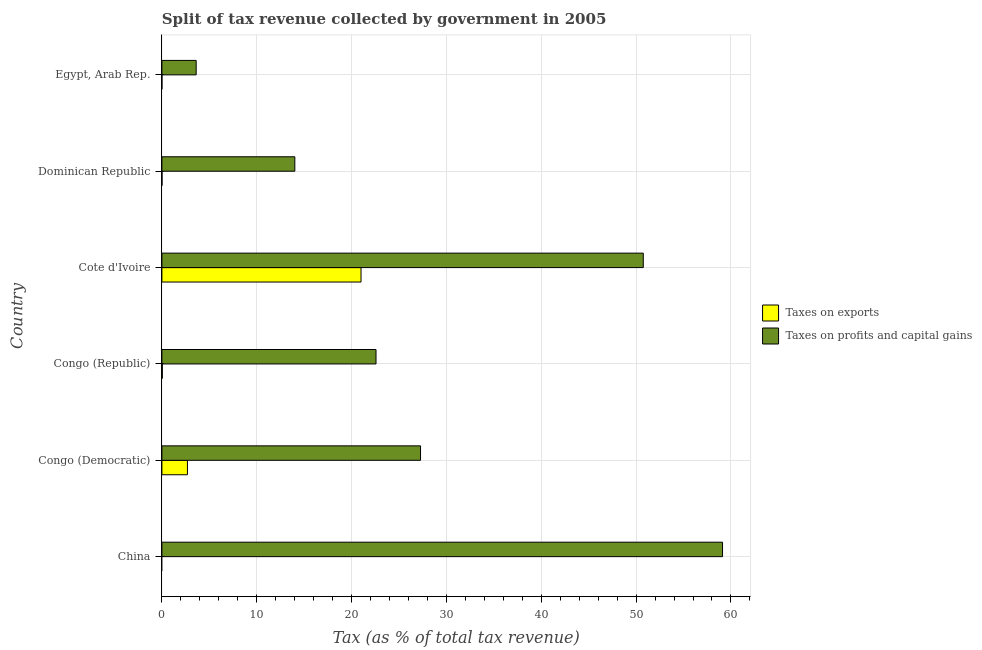How many different coloured bars are there?
Provide a succinct answer. 2. How many bars are there on the 3rd tick from the top?
Provide a short and direct response. 2. What is the label of the 5th group of bars from the top?
Give a very brief answer. Congo (Democratic). In how many cases, is the number of bars for a given country not equal to the number of legend labels?
Ensure brevity in your answer.  1. What is the percentage of revenue obtained from taxes on exports in Congo (Democratic)?
Offer a terse response. 2.69. Across all countries, what is the maximum percentage of revenue obtained from taxes on profits and capital gains?
Your response must be concise. 59.11. Across all countries, what is the minimum percentage of revenue obtained from taxes on exports?
Your response must be concise. 0. In which country was the percentage of revenue obtained from taxes on exports maximum?
Make the answer very short. Cote d'Ivoire. What is the total percentage of revenue obtained from taxes on profits and capital gains in the graph?
Provide a succinct answer. 177.34. What is the difference between the percentage of revenue obtained from taxes on profits and capital gains in Congo (Republic) and that in Cote d'Ivoire?
Provide a succinct answer. -28.18. What is the difference between the percentage of revenue obtained from taxes on exports in Dominican Republic and the percentage of revenue obtained from taxes on profits and capital gains in Cote d'Ivoire?
Your answer should be very brief. -50.75. What is the average percentage of revenue obtained from taxes on profits and capital gains per country?
Keep it short and to the point. 29.56. What is the difference between the percentage of revenue obtained from taxes on exports and percentage of revenue obtained from taxes on profits and capital gains in Congo (Republic)?
Your answer should be very brief. -22.53. In how many countries, is the percentage of revenue obtained from taxes on profits and capital gains greater than 54 %?
Give a very brief answer. 1. What is the ratio of the percentage of revenue obtained from taxes on profits and capital gains in Congo (Democratic) to that in Egypt, Arab Rep.?
Provide a short and direct response. 7.55. Is the percentage of revenue obtained from taxes on exports in Cote d'Ivoire less than that in Egypt, Arab Rep.?
Your answer should be compact. No. What is the difference between the highest and the second highest percentage of revenue obtained from taxes on profits and capital gains?
Offer a terse response. 8.36. What is the difference between the highest and the lowest percentage of revenue obtained from taxes on profits and capital gains?
Ensure brevity in your answer.  55.5. Is the sum of the percentage of revenue obtained from taxes on profits and capital gains in China and Cote d'Ivoire greater than the maximum percentage of revenue obtained from taxes on exports across all countries?
Make the answer very short. Yes. Are the values on the major ticks of X-axis written in scientific E-notation?
Give a very brief answer. No. How are the legend labels stacked?
Your answer should be compact. Vertical. What is the title of the graph?
Offer a very short reply. Split of tax revenue collected by government in 2005. What is the label or title of the X-axis?
Your response must be concise. Tax (as % of total tax revenue). What is the label or title of the Y-axis?
Ensure brevity in your answer.  Country. What is the Tax (as % of total tax revenue) of Taxes on profits and capital gains in China?
Provide a succinct answer. 59.11. What is the Tax (as % of total tax revenue) of Taxes on exports in Congo (Democratic)?
Provide a succinct answer. 2.69. What is the Tax (as % of total tax revenue) of Taxes on profits and capital gains in Congo (Democratic)?
Your response must be concise. 27.27. What is the Tax (as % of total tax revenue) in Taxes on exports in Congo (Republic)?
Offer a very short reply. 0.05. What is the Tax (as % of total tax revenue) in Taxes on profits and capital gains in Congo (Republic)?
Make the answer very short. 22.58. What is the Tax (as % of total tax revenue) of Taxes on exports in Cote d'Ivoire?
Keep it short and to the point. 21. What is the Tax (as % of total tax revenue) of Taxes on profits and capital gains in Cote d'Ivoire?
Offer a terse response. 50.76. What is the Tax (as % of total tax revenue) of Taxes on exports in Dominican Republic?
Make the answer very short. 0.01. What is the Tax (as % of total tax revenue) of Taxes on profits and capital gains in Dominican Republic?
Your answer should be compact. 14.02. What is the Tax (as % of total tax revenue) in Taxes on exports in Egypt, Arab Rep.?
Your answer should be compact. 0. What is the Tax (as % of total tax revenue) in Taxes on profits and capital gains in Egypt, Arab Rep.?
Provide a succinct answer. 3.61. Across all countries, what is the maximum Tax (as % of total tax revenue) of Taxes on exports?
Keep it short and to the point. 21. Across all countries, what is the maximum Tax (as % of total tax revenue) in Taxes on profits and capital gains?
Provide a short and direct response. 59.11. Across all countries, what is the minimum Tax (as % of total tax revenue) in Taxes on profits and capital gains?
Offer a terse response. 3.61. What is the total Tax (as % of total tax revenue) of Taxes on exports in the graph?
Provide a short and direct response. 23.74. What is the total Tax (as % of total tax revenue) of Taxes on profits and capital gains in the graph?
Ensure brevity in your answer.  177.34. What is the difference between the Tax (as % of total tax revenue) of Taxes on profits and capital gains in China and that in Congo (Democratic)?
Offer a terse response. 31.84. What is the difference between the Tax (as % of total tax revenue) of Taxes on profits and capital gains in China and that in Congo (Republic)?
Ensure brevity in your answer.  36.54. What is the difference between the Tax (as % of total tax revenue) of Taxes on profits and capital gains in China and that in Cote d'Ivoire?
Your response must be concise. 8.36. What is the difference between the Tax (as % of total tax revenue) of Taxes on profits and capital gains in China and that in Dominican Republic?
Offer a terse response. 45.1. What is the difference between the Tax (as % of total tax revenue) of Taxes on profits and capital gains in China and that in Egypt, Arab Rep.?
Make the answer very short. 55.5. What is the difference between the Tax (as % of total tax revenue) in Taxes on exports in Congo (Democratic) and that in Congo (Republic)?
Your response must be concise. 2.65. What is the difference between the Tax (as % of total tax revenue) of Taxes on profits and capital gains in Congo (Democratic) and that in Congo (Republic)?
Provide a succinct answer. 4.69. What is the difference between the Tax (as % of total tax revenue) in Taxes on exports in Congo (Democratic) and that in Cote d'Ivoire?
Ensure brevity in your answer.  -18.3. What is the difference between the Tax (as % of total tax revenue) of Taxes on profits and capital gains in Congo (Democratic) and that in Cote d'Ivoire?
Offer a very short reply. -23.49. What is the difference between the Tax (as % of total tax revenue) of Taxes on exports in Congo (Democratic) and that in Dominican Republic?
Ensure brevity in your answer.  2.68. What is the difference between the Tax (as % of total tax revenue) in Taxes on profits and capital gains in Congo (Democratic) and that in Dominican Republic?
Your answer should be compact. 13.25. What is the difference between the Tax (as % of total tax revenue) in Taxes on exports in Congo (Democratic) and that in Egypt, Arab Rep.?
Provide a succinct answer. 2.69. What is the difference between the Tax (as % of total tax revenue) of Taxes on profits and capital gains in Congo (Democratic) and that in Egypt, Arab Rep.?
Ensure brevity in your answer.  23.66. What is the difference between the Tax (as % of total tax revenue) of Taxes on exports in Congo (Republic) and that in Cote d'Ivoire?
Offer a terse response. -20.95. What is the difference between the Tax (as % of total tax revenue) of Taxes on profits and capital gains in Congo (Republic) and that in Cote d'Ivoire?
Offer a terse response. -28.18. What is the difference between the Tax (as % of total tax revenue) of Taxes on exports in Congo (Republic) and that in Dominican Republic?
Your answer should be very brief. 0.04. What is the difference between the Tax (as % of total tax revenue) in Taxes on profits and capital gains in Congo (Republic) and that in Dominican Republic?
Your answer should be very brief. 8.56. What is the difference between the Tax (as % of total tax revenue) in Taxes on exports in Congo (Republic) and that in Egypt, Arab Rep.?
Offer a terse response. 0.04. What is the difference between the Tax (as % of total tax revenue) in Taxes on profits and capital gains in Congo (Republic) and that in Egypt, Arab Rep.?
Provide a succinct answer. 18.96. What is the difference between the Tax (as % of total tax revenue) of Taxes on exports in Cote d'Ivoire and that in Dominican Republic?
Your answer should be compact. 20.99. What is the difference between the Tax (as % of total tax revenue) in Taxes on profits and capital gains in Cote d'Ivoire and that in Dominican Republic?
Offer a terse response. 36.74. What is the difference between the Tax (as % of total tax revenue) in Taxes on exports in Cote d'Ivoire and that in Egypt, Arab Rep.?
Your answer should be very brief. 20.99. What is the difference between the Tax (as % of total tax revenue) in Taxes on profits and capital gains in Cote d'Ivoire and that in Egypt, Arab Rep.?
Your answer should be compact. 47.14. What is the difference between the Tax (as % of total tax revenue) in Taxes on exports in Dominican Republic and that in Egypt, Arab Rep.?
Offer a terse response. 0.01. What is the difference between the Tax (as % of total tax revenue) in Taxes on profits and capital gains in Dominican Republic and that in Egypt, Arab Rep.?
Ensure brevity in your answer.  10.4. What is the difference between the Tax (as % of total tax revenue) in Taxes on exports in Congo (Democratic) and the Tax (as % of total tax revenue) in Taxes on profits and capital gains in Congo (Republic)?
Offer a terse response. -19.88. What is the difference between the Tax (as % of total tax revenue) of Taxes on exports in Congo (Democratic) and the Tax (as % of total tax revenue) of Taxes on profits and capital gains in Cote d'Ivoire?
Your answer should be compact. -48.06. What is the difference between the Tax (as % of total tax revenue) in Taxes on exports in Congo (Democratic) and the Tax (as % of total tax revenue) in Taxes on profits and capital gains in Dominican Republic?
Offer a very short reply. -11.32. What is the difference between the Tax (as % of total tax revenue) of Taxes on exports in Congo (Democratic) and the Tax (as % of total tax revenue) of Taxes on profits and capital gains in Egypt, Arab Rep.?
Offer a terse response. -0.92. What is the difference between the Tax (as % of total tax revenue) of Taxes on exports in Congo (Republic) and the Tax (as % of total tax revenue) of Taxes on profits and capital gains in Cote d'Ivoire?
Provide a short and direct response. -50.71. What is the difference between the Tax (as % of total tax revenue) of Taxes on exports in Congo (Republic) and the Tax (as % of total tax revenue) of Taxes on profits and capital gains in Dominican Republic?
Provide a short and direct response. -13.97. What is the difference between the Tax (as % of total tax revenue) of Taxes on exports in Congo (Republic) and the Tax (as % of total tax revenue) of Taxes on profits and capital gains in Egypt, Arab Rep.?
Your response must be concise. -3.57. What is the difference between the Tax (as % of total tax revenue) of Taxes on exports in Cote d'Ivoire and the Tax (as % of total tax revenue) of Taxes on profits and capital gains in Dominican Republic?
Provide a succinct answer. 6.98. What is the difference between the Tax (as % of total tax revenue) in Taxes on exports in Cote d'Ivoire and the Tax (as % of total tax revenue) in Taxes on profits and capital gains in Egypt, Arab Rep.?
Offer a very short reply. 17.38. What is the difference between the Tax (as % of total tax revenue) in Taxes on exports in Dominican Republic and the Tax (as % of total tax revenue) in Taxes on profits and capital gains in Egypt, Arab Rep.?
Provide a short and direct response. -3.6. What is the average Tax (as % of total tax revenue) in Taxes on exports per country?
Provide a short and direct response. 3.96. What is the average Tax (as % of total tax revenue) in Taxes on profits and capital gains per country?
Make the answer very short. 29.56. What is the difference between the Tax (as % of total tax revenue) in Taxes on exports and Tax (as % of total tax revenue) in Taxes on profits and capital gains in Congo (Democratic)?
Keep it short and to the point. -24.58. What is the difference between the Tax (as % of total tax revenue) of Taxes on exports and Tax (as % of total tax revenue) of Taxes on profits and capital gains in Congo (Republic)?
Your answer should be compact. -22.53. What is the difference between the Tax (as % of total tax revenue) in Taxes on exports and Tax (as % of total tax revenue) in Taxes on profits and capital gains in Cote d'Ivoire?
Your response must be concise. -29.76. What is the difference between the Tax (as % of total tax revenue) in Taxes on exports and Tax (as % of total tax revenue) in Taxes on profits and capital gains in Dominican Republic?
Give a very brief answer. -14.01. What is the difference between the Tax (as % of total tax revenue) of Taxes on exports and Tax (as % of total tax revenue) of Taxes on profits and capital gains in Egypt, Arab Rep.?
Make the answer very short. -3.61. What is the ratio of the Tax (as % of total tax revenue) of Taxes on profits and capital gains in China to that in Congo (Democratic)?
Make the answer very short. 2.17. What is the ratio of the Tax (as % of total tax revenue) of Taxes on profits and capital gains in China to that in Congo (Republic)?
Your answer should be compact. 2.62. What is the ratio of the Tax (as % of total tax revenue) of Taxes on profits and capital gains in China to that in Cote d'Ivoire?
Your response must be concise. 1.16. What is the ratio of the Tax (as % of total tax revenue) in Taxes on profits and capital gains in China to that in Dominican Republic?
Ensure brevity in your answer.  4.22. What is the ratio of the Tax (as % of total tax revenue) in Taxes on profits and capital gains in China to that in Egypt, Arab Rep.?
Your answer should be very brief. 16.36. What is the ratio of the Tax (as % of total tax revenue) in Taxes on exports in Congo (Democratic) to that in Congo (Republic)?
Provide a short and direct response. 59.33. What is the ratio of the Tax (as % of total tax revenue) in Taxes on profits and capital gains in Congo (Democratic) to that in Congo (Republic)?
Provide a short and direct response. 1.21. What is the ratio of the Tax (as % of total tax revenue) in Taxes on exports in Congo (Democratic) to that in Cote d'Ivoire?
Provide a succinct answer. 0.13. What is the ratio of the Tax (as % of total tax revenue) of Taxes on profits and capital gains in Congo (Democratic) to that in Cote d'Ivoire?
Ensure brevity in your answer.  0.54. What is the ratio of the Tax (as % of total tax revenue) in Taxes on exports in Congo (Democratic) to that in Dominican Republic?
Give a very brief answer. 294.57. What is the ratio of the Tax (as % of total tax revenue) of Taxes on profits and capital gains in Congo (Democratic) to that in Dominican Republic?
Keep it short and to the point. 1.95. What is the ratio of the Tax (as % of total tax revenue) of Taxes on exports in Congo (Democratic) to that in Egypt, Arab Rep.?
Offer a terse response. 2039.87. What is the ratio of the Tax (as % of total tax revenue) of Taxes on profits and capital gains in Congo (Democratic) to that in Egypt, Arab Rep.?
Your answer should be compact. 7.55. What is the ratio of the Tax (as % of total tax revenue) of Taxes on exports in Congo (Republic) to that in Cote d'Ivoire?
Keep it short and to the point. 0. What is the ratio of the Tax (as % of total tax revenue) of Taxes on profits and capital gains in Congo (Republic) to that in Cote d'Ivoire?
Your answer should be very brief. 0.44. What is the ratio of the Tax (as % of total tax revenue) of Taxes on exports in Congo (Republic) to that in Dominican Republic?
Your answer should be compact. 4.97. What is the ratio of the Tax (as % of total tax revenue) of Taxes on profits and capital gains in Congo (Republic) to that in Dominican Republic?
Keep it short and to the point. 1.61. What is the ratio of the Tax (as % of total tax revenue) in Taxes on exports in Congo (Republic) to that in Egypt, Arab Rep.?
Offer a terse response. 34.38. What is the ratio of the Tax (as % of total tax revenue) of Taxes on profits and capital gains in Congo (Republic) to that in Egypt, Arab Rep.?
Make the answer very short. 6.25. What is the ratio of the Tax (as % of total tax revenue) of Taxes on exports in Cote d'Ivoire to that in Dominican Republic?
Your answer should be very brief. 2296.94. What is the ratio of the Tax (as % of total tax revenue) in Taxes on profits and capital gains in Cote d'Ivoire to that in Dominican Republic?
Ensure brevity in your answer.  3.62. What is the ratio of the Tax (as % of total tax revenue) in Taxes on exports in Cote d'Ivoire to that in Egypt, Arab Rep.?
Ensure brevity in your answer.  1.59e+04. What is the ratio of the Tax (as % of total tax revenue) of Taxes on profits and capital gains in Cote d'Ivoire to that in Egypt, Arab Rep.?
Your response must be concise. 14.05. What is the ratio of the Tax (as % of total tax revenue) in Taxes on exports in Dominican Republic to that in Egypt, Arab Rep.?
Offer a terse response. 6.92. What is the ratio of the Tax (as % of total tax revenue) in Taxes on profits and capital gains in Dominican Republic to that in Egypt, Arab Rep.?
Your answer should be very brief. 3.88. What is the difference between the highest and the second highest Tax (as % of total tax revenue) of Taxes on exports?
Your answer should be very brief. 18.3. What is the difference between the highest and the second highest Tax (as % of total tax revenue) of Taxes on profits and capital gains?
Your answer should be compact. 8.36. What is the difference between the highest and the lowest Tax (as % of total tax revenue) in Taxes on exports?
Your answer should be very brief. 21. What is the difference between the highest and the lowest Tax (as % of total tax revenue) of Taxes on profits and capital gains?
Offer a terse response. 55.5. 